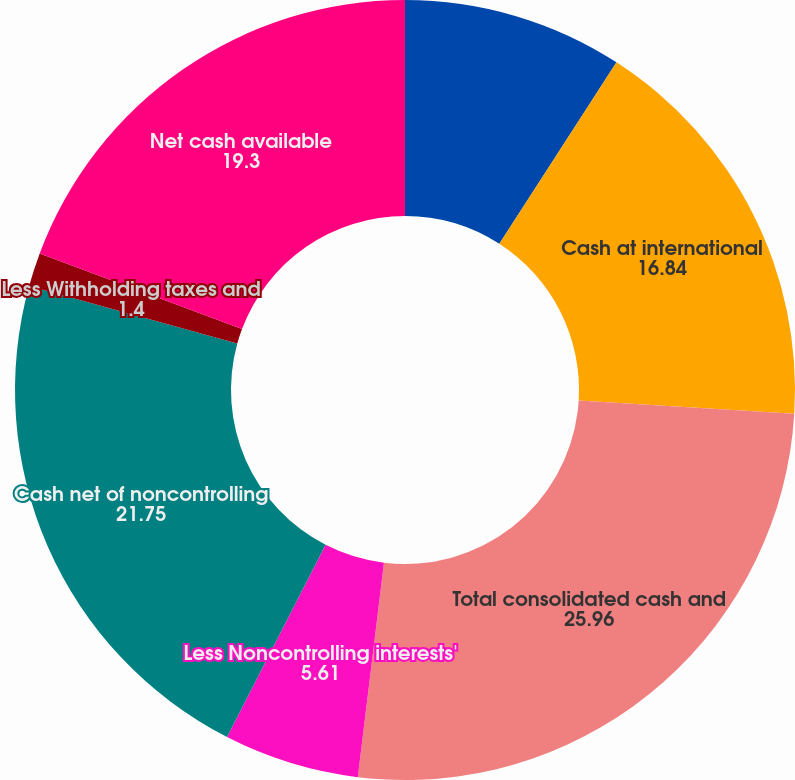<chart> <loc_0><loc_0><loc_500><loc_500><pie_chart><fcel>Cash at domestic companies^a<fcel>Cash at international<fcel>Total consolidated cash and<fcel>Less Noncontrolling interests'<fcel>Cash net of noncontrolling<fcel>Less Withholding taxes and<fcel>Net cash available<nl><fcel>9.12%<fcel>16.84%<fcel>25.96%<fcel>5.61%<fcel>21.75%<fcel>1.4%<fcel>19.3%<nl></chart> 